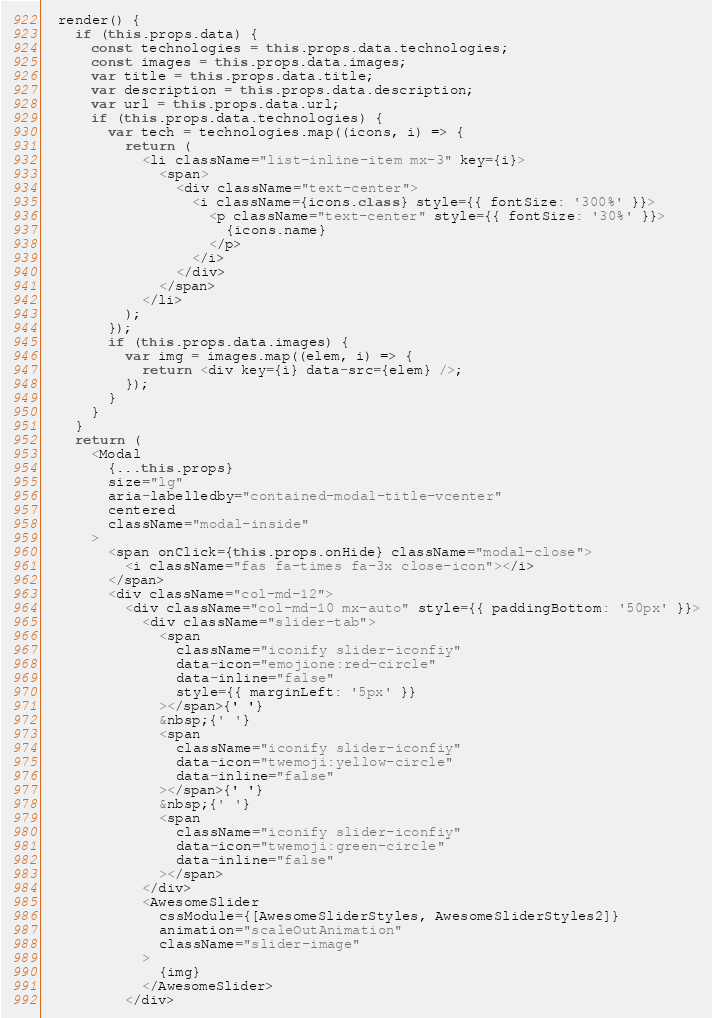<code> <loc_0><loc_0><loc_500><loc_500><_JavaScript_>  render() {
    if (this.props.data) {
      const technologies = this.props.data.technologies;
      const images = this.props.data.images;
      var title = this.props.data.title;
      var description = this.props.data.description;
      var url = this.props.data.url;
      if (this.props.data.technologies) {
        var tech = technologies.map((icons, i) => {
          return (
            <li className="list-inline-item mx-3" key={i}>
              <span>
                <div className="text-center">
                  <i className={icons.class} style={{ fontSize: '300%' }}>
                    <p className="text-center" style={{ fontSize: '30%' }}>
                      {icons.name}
                    </p>
                  </i>
                </div>
              </span>
            </li>
          );
        });
        if (this.props.data.images) {
          var img = images.map((elem, i) => {
            return <div key={i} data-src={elem} />;
          });
        }
      }
    }
    return (
      <Modal
        {...this.props}
        size="lg"
        aria-labelledby="contained-modal-title-vcenter"
        centered
        className="modal-inside"
      >
        <span onClick={this.props.onHide} className="modal-close">
          <i className="fas fa-times fa-3x close-icon"></i>
        </span>
        <div className="col-md-12">
          <div className="col-md-10 mx-auto" style={{ paddingBottom: '50px' }}>
            <div className="slider-tab">
              <span
                className="iconify slider-iconfiy"
                data-icon="emojione:red-circle"
                data-inline="false"
                style={{ marginLeft: '5px' }}
              ></span>{' '}
              &nbsp;{' '}
              <span
                className="iconify slider-iconfiy"
                data-icon="twemoji:yellow-circle"
                data-inline="false"
              ></span>{' '}
              &nbsp;{' '}
              <span
                className="iconify slider-iconfiy"
                data-icon="twemoji:green-circle"
                data-inline="false"
              ></span>
            </div>
            <AwesomeSlider
              cssModule={[AwesomeSliderStyles, AwesomeSliderStyles2]}
              animation="scaleOutAnimation"
              className="slider-image"
            >
              {img}
            </AwesomeSlider>
          </div></code> 